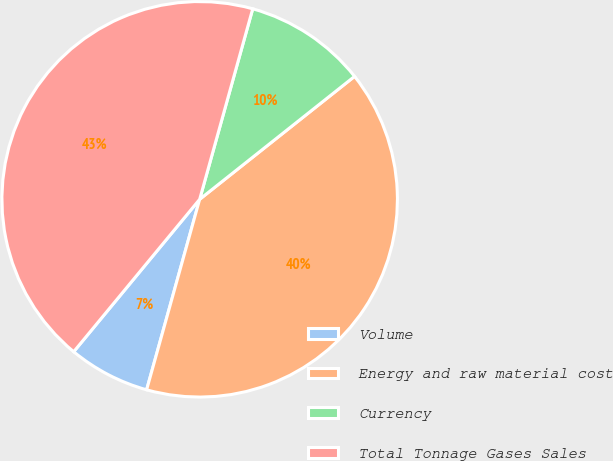Convert chart to OTSL. <chart><loc_0><loc_0><loc_500><loc_500><pie_chart><fcel>Volume<fcel>Energy and raw material cost<fcel>Currency<fcel>Total Tonnage Gases Sales<nl><fcel>6.67%<fcel>40.0%<fcel>10.0%<fcel>43.33%<nl></chart> 